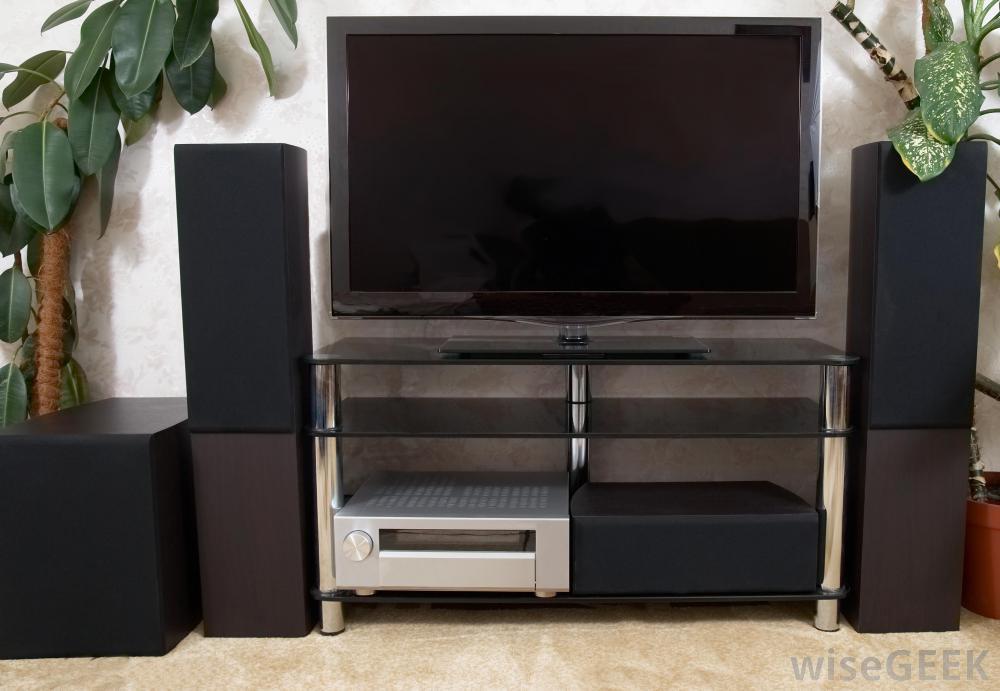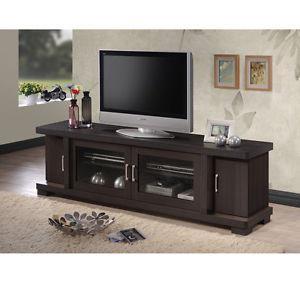The first image is the image on the left, the second image is the image on the right. Considering the images on both sides, is "One picture is sitting on a TV stand next to the TV." valid? Answer yes or no. Yes. The first image is the image on the left, the second image is the image on the right. Given the left and right images, does the statement "One image shows a flatscreen TV on a low-slung stand with solid doors on each end and two open shelves in the middle." hold true? Answer yes or no. No. 